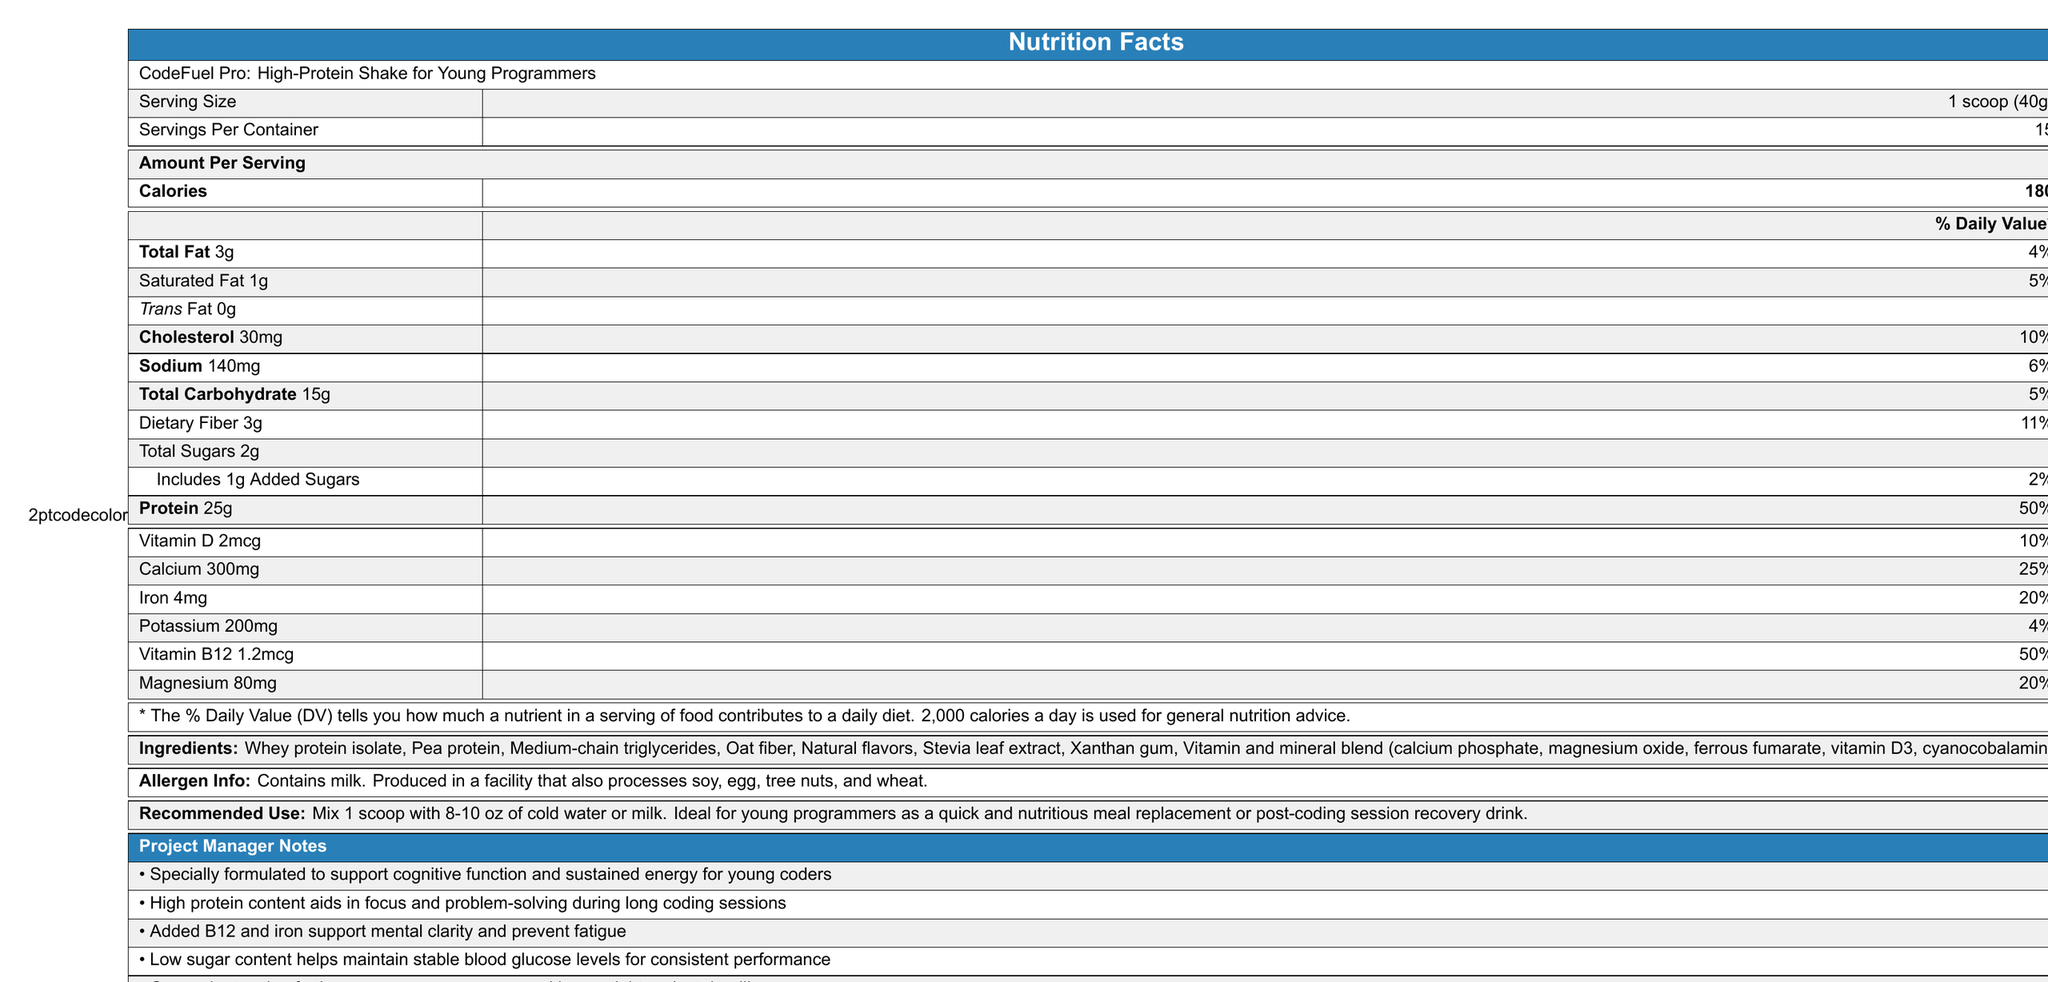What is the serving size? The serving size is clearly stated on the Nutrition Facts Label as 1 scoop (40g).
Answer: 1 scoop (40g) How many calories are in each serving? The calories per serving are listed as 180 on the Nutrition Facts Label.
Answer: 180 What is the total fat content per serving? The Nutrition Facts Label indicates that the total fat content per serving is 3g.
Answer: 3g How much protein does one serving contain? The amount of protein per serving is listed as 25g on the Nutrition Facts Label.
Answer: 25g What percentage of the daily value of calcium does one serving provide? The Nutrition Facts Label shows that one serving provides 25% of the daily value for calcium.
Answer: 25% What is the amount of dietary fiber per serving? According to the Nutrition Facts Label, each serving contains 3g of dietary fiber.
Answer: 3g Which of the following is included as an ingredient in the shake? A. Soy Protein B. Stevia Leaf Extract C. Corn Syrup The ingredients list includes Stevia Leaf Extract but not Soy Protein or Corn Syrup.
Answer: B What are the added sugars in one serving? A. 1g B. 2g C. 3g D. 4g The Nutrition Facts Label specifies that the added sugars amount to 1g per serving.
Answer: A Is there any trans fat in this shake? The Nutrition Facts Label states that there is 0g of trans fat per serving.
Answer: No Summarize the main aim of CodeFuel Pro: High-Protein Shake for Young Programmers. The nutritional and ingredient details, alongside the project manager notes, collectively indicate that the shake aims to support young programmers with high protein content, low sugars, essential vitamins and minerals, and is convenient for busy schedules.
Answer: The shake is designed to support cognitive function, provide sustained energy, aid in focus and problem-solving, maintain stable blood glucose levels, prevent fatigue, and serve as a convenient meal replacement for young programmers. What is the percent daily value of Vitamin B12 in one serving? The Nutrition Facts Label shows that one serving provides 50% of the daily value for Vitamin B12.
Answer: 50% How many servings are there per container? The Nutrition Facts Label states that there are 15 servings per container.
Answer: 15 What is the main source of protein in CodeFuel Pro? The ingredients list specifies that Whey protein isolate and Pea protein are the sources of protein.
Answer: Whey protein isolate and Pea protein Does this product contain milk? The allergen information clearly states that the product contains milk.
Answer: Yes What is the recommended use of this shake? The recommended use is detailed on the Nutrition Facts Label.
Answer: Mix 1 scoop with 8-10 oz of cold water or milk. Ideal for young programmers as a quick and nutritious meal replacement or post-coding session recovery drink. What is the total amount of sugars in one serving? The Nutrition Facts Label indicates that the total sugars per serving are 2g.
Answer: 2g How much iron does one serving contain? The Nutrition Facts Label shows that one serving contains 4mg of iron.
Answer: 4mg What is the serving size in grams? The serving size is specified as 1 scoop, which is equivalent to 40g.
Answer: 40g How many milligrams of potassium are in one serving? The Nutrition Facts Label indicates that there are 200mg of potassium in one serving.
Answer: 200mg Can the precise benefits code be determined from this document? The document provides nutritional details and usage recommendations but not the specific "benefits code."
Answer: Not enough information What is the percentage of daily value for cholesterol in one serving? The Nutrition Facts Label specifies that one serving provides 10% of the daily value for cholesterol.
Answer: 10% 